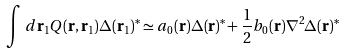<formula> <loc_0><loc_0><loc_500><loc_500>\int \, d { \mathbf r } _ { 1 } Q ( { \mathbf r } , { \mathbf r } _ { 1 } ) \Delta ( { \mathbf r } _ { 1 } ) ^ { * } \simeq a _ { 0 } ( { \mathbf r } ) \Delta ( { \mathbf r } ) ^ { * } + \frac { 1 } { 2 } b _ { 0 } ( { \mathbf r } ) \nabla ^ { 2 } \Delta ( { \mathbf r } ) ^ { * }</formula> 